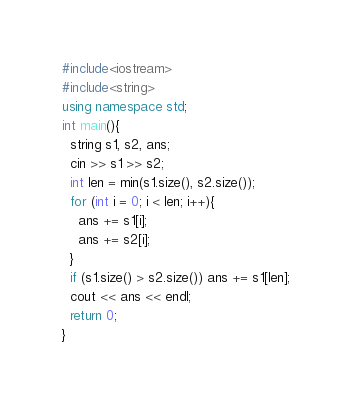<code> <loc_0><loc_0><loc_500><loc_500><_C++_>#include<iostream>
#include<string>
using namespace std;
int main(){
  string s1, s2, ans;
  cin >> s1 >> s2;
  int len = min(s1.size(), s2.size());
  for (int i = 0; i < len; i++){
    ans += s1[i];
    ans += s2[i];
  }
  if (s1.size() > s2.size()) ans += s1[len];
  cout << ans << endl;
  return 0;
}</code> 